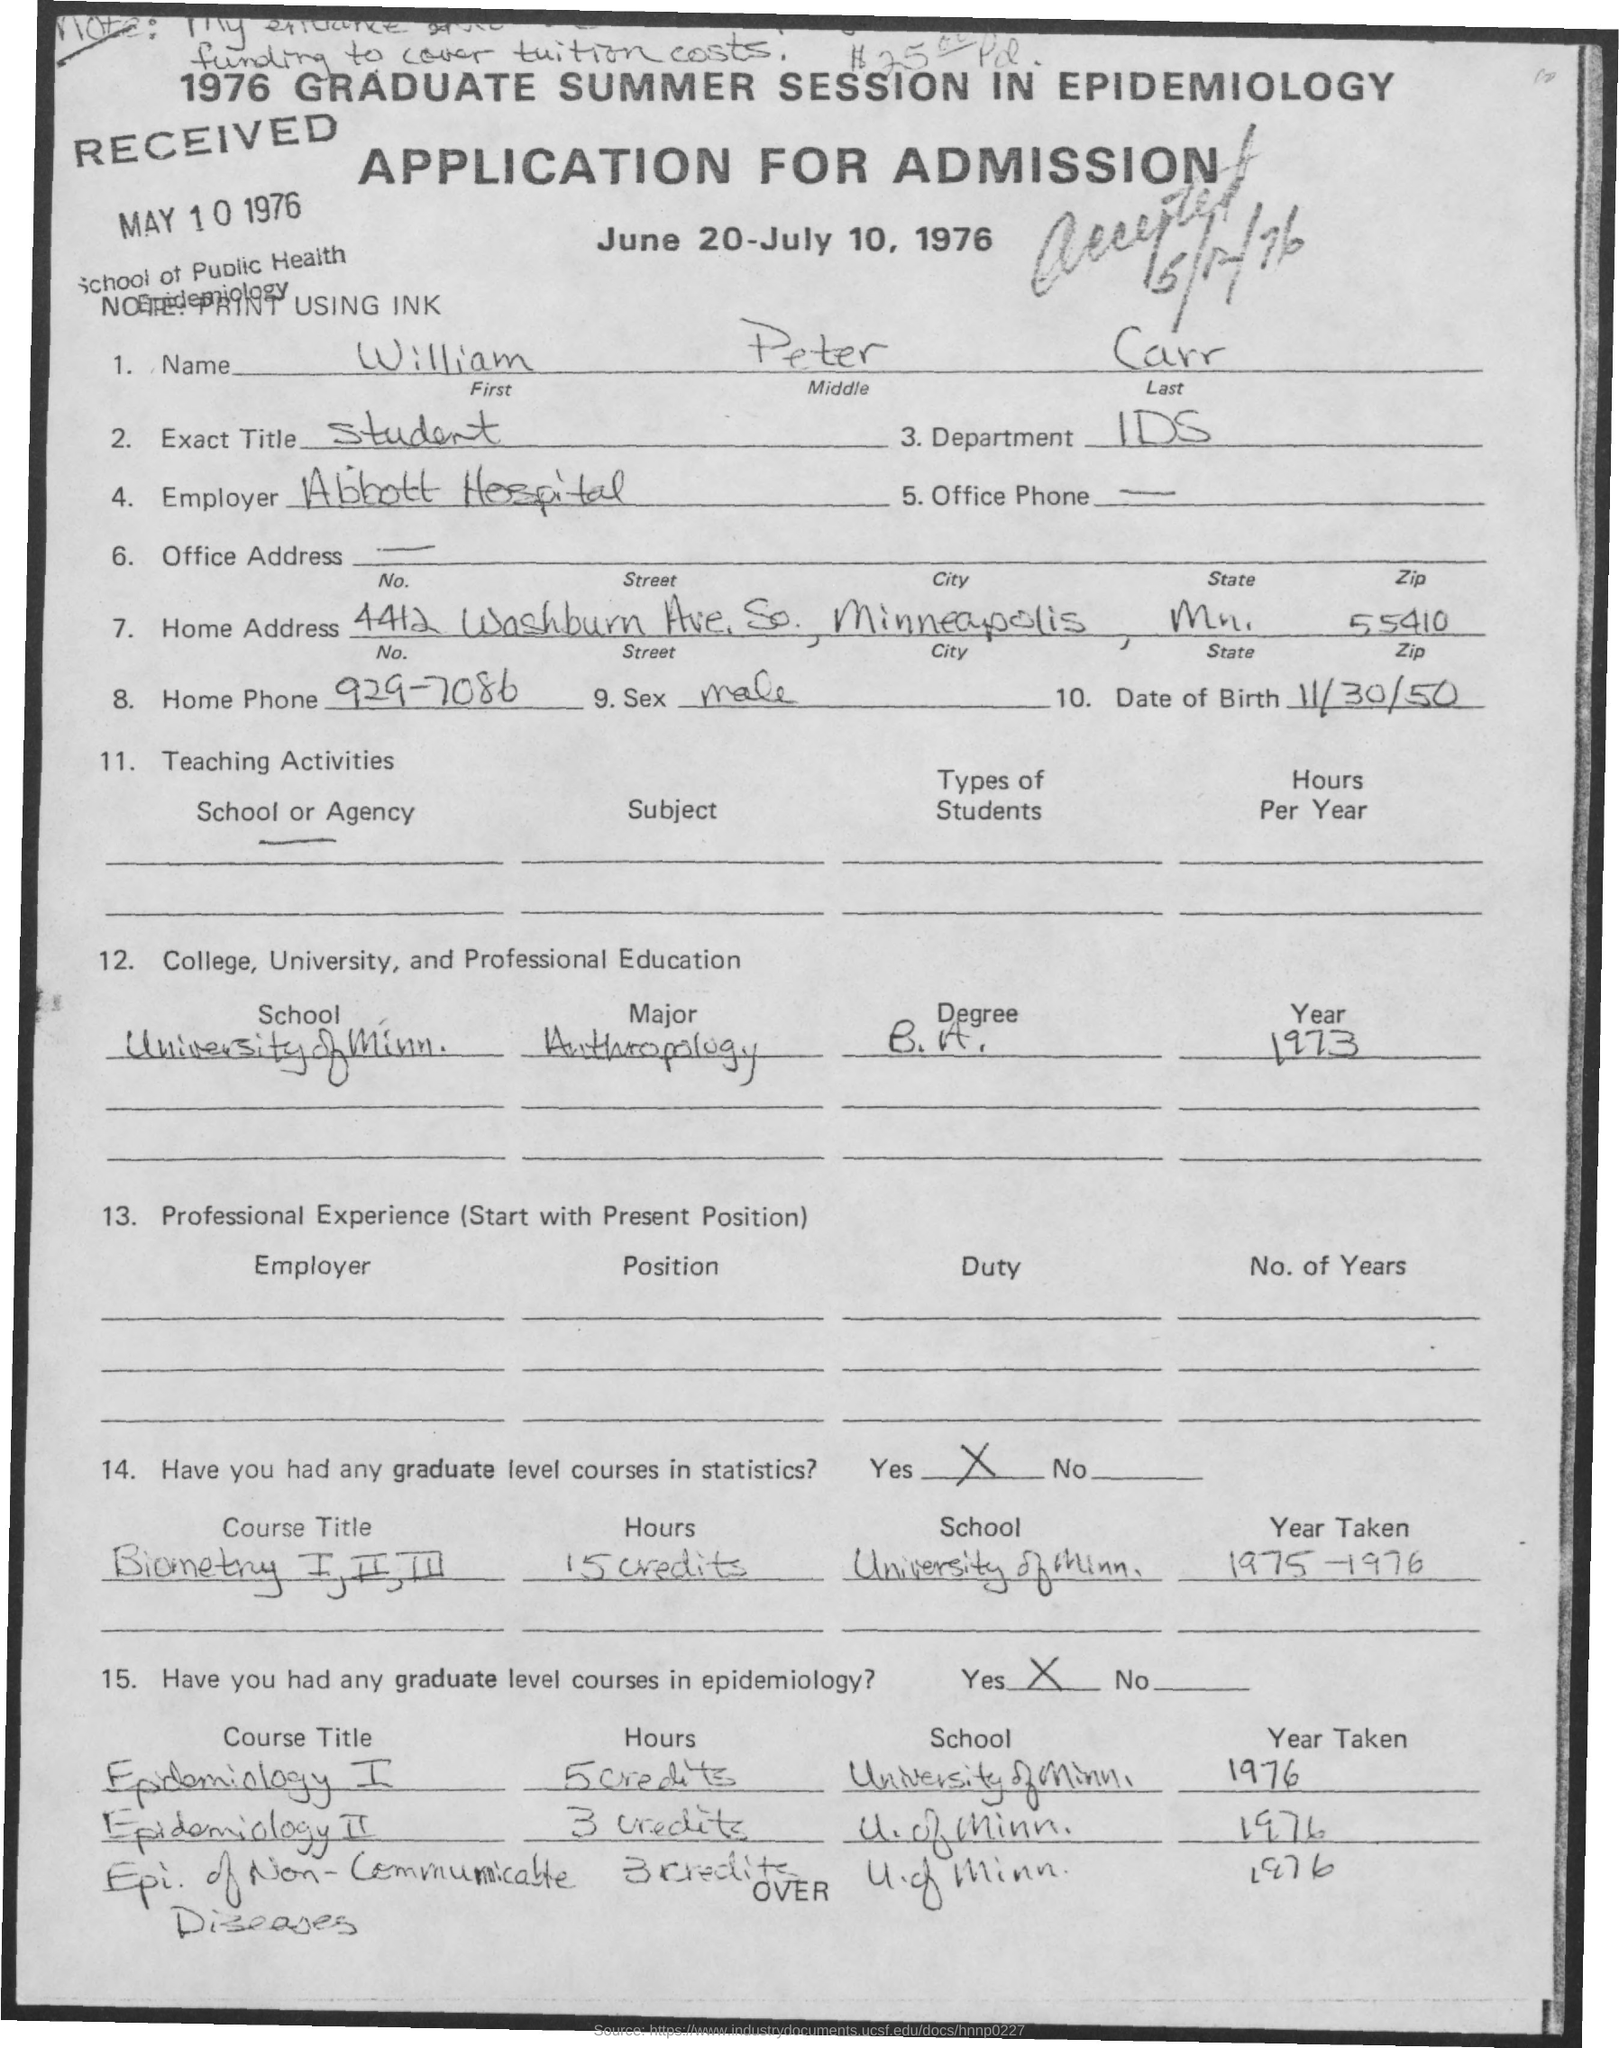What is the first name mentioned in the given application ?
Provide a succinct answer. William. What is the middle name as mentioned in the given application ?
Make the answer very short. Peter. What is the last name as mentioned in the given application ?
Provide a succinct answer. Carr. What is the exact title mentioned in the given application ?
Your answer should be very brief. Student. What is the name of the department mentioned in the given application ?
Your answer should be very brief. IDS. On which date the application was received ?
Provide a succinct answer. MAY 10 , 1976. What is the home phone number mentioned in the given application ?
Provide a succinct answer. 929-7086. What is the sex mentioned in the given application ?
Keep it short and to the point. Male. What is the date of birth mentioned in the given application ?
Offer a very short reply. 11/30/50. 